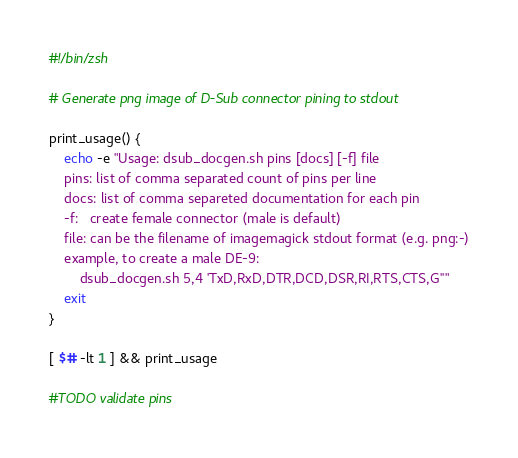Convert code to text. <code><loc_0><loc_0><loc_500><loc_500><_Bash_>#!/bin/zsh

# Generate png image of D-Sub connector pining to stdout

print_usage() {
    echo -e "Usage: dsub_docgen.sh pins [docs] [-f] file
    pins: list of comma separated count of pins per line
    docs: list of comma separeted documentation for each pin
    -f:   create female connector (male is default)
    file: can be the filename of imagemagick stdout format (e.g. png:-)
    example, to create a male DE-9:
        dsub_docgen.sh 5,4 'TxD,RxD,DTR,DCD,DSR,RI,RTS,CTS,G''"
    exit
}

[ $# -lt 1 ] && print_usage

#TODO validate pins</code> 